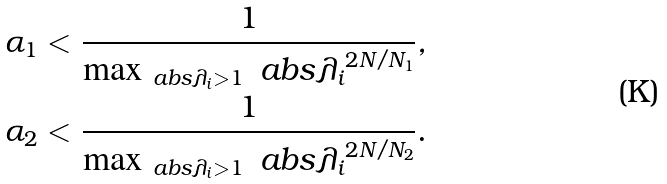Convert formula to latex. <formula><loc_0><loc_0><loc_500><loc_500>\alpha _ { 1 } & < \frac { 1 } { \max _ { \ a b s { \lambda _ { i } } > 1 } \ a b s { \lambda _ { i } } ^ { 2 N / N _ { 1 } } } , \\ \alpha _ { 2 } & < \frac { 1 } { \max _ { \ a b s { \lambda _ { i } } > 1 } \ a b s { \lambda _ { i } } ^ { 2 N / N _ { 2 } } } .</formula> 